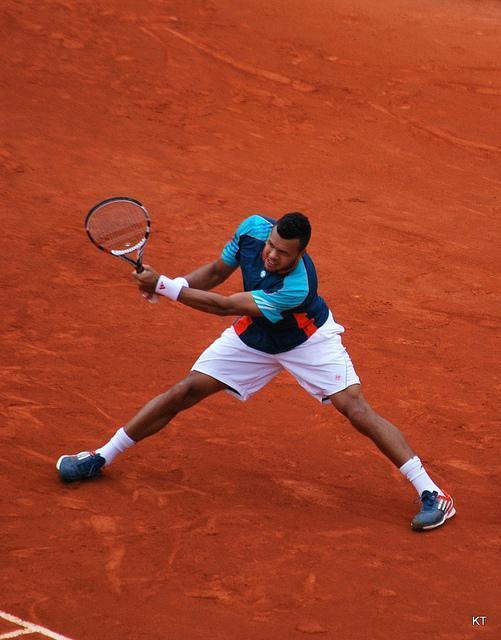How many cats are on the desk?
Give a very brief answer. 0. 